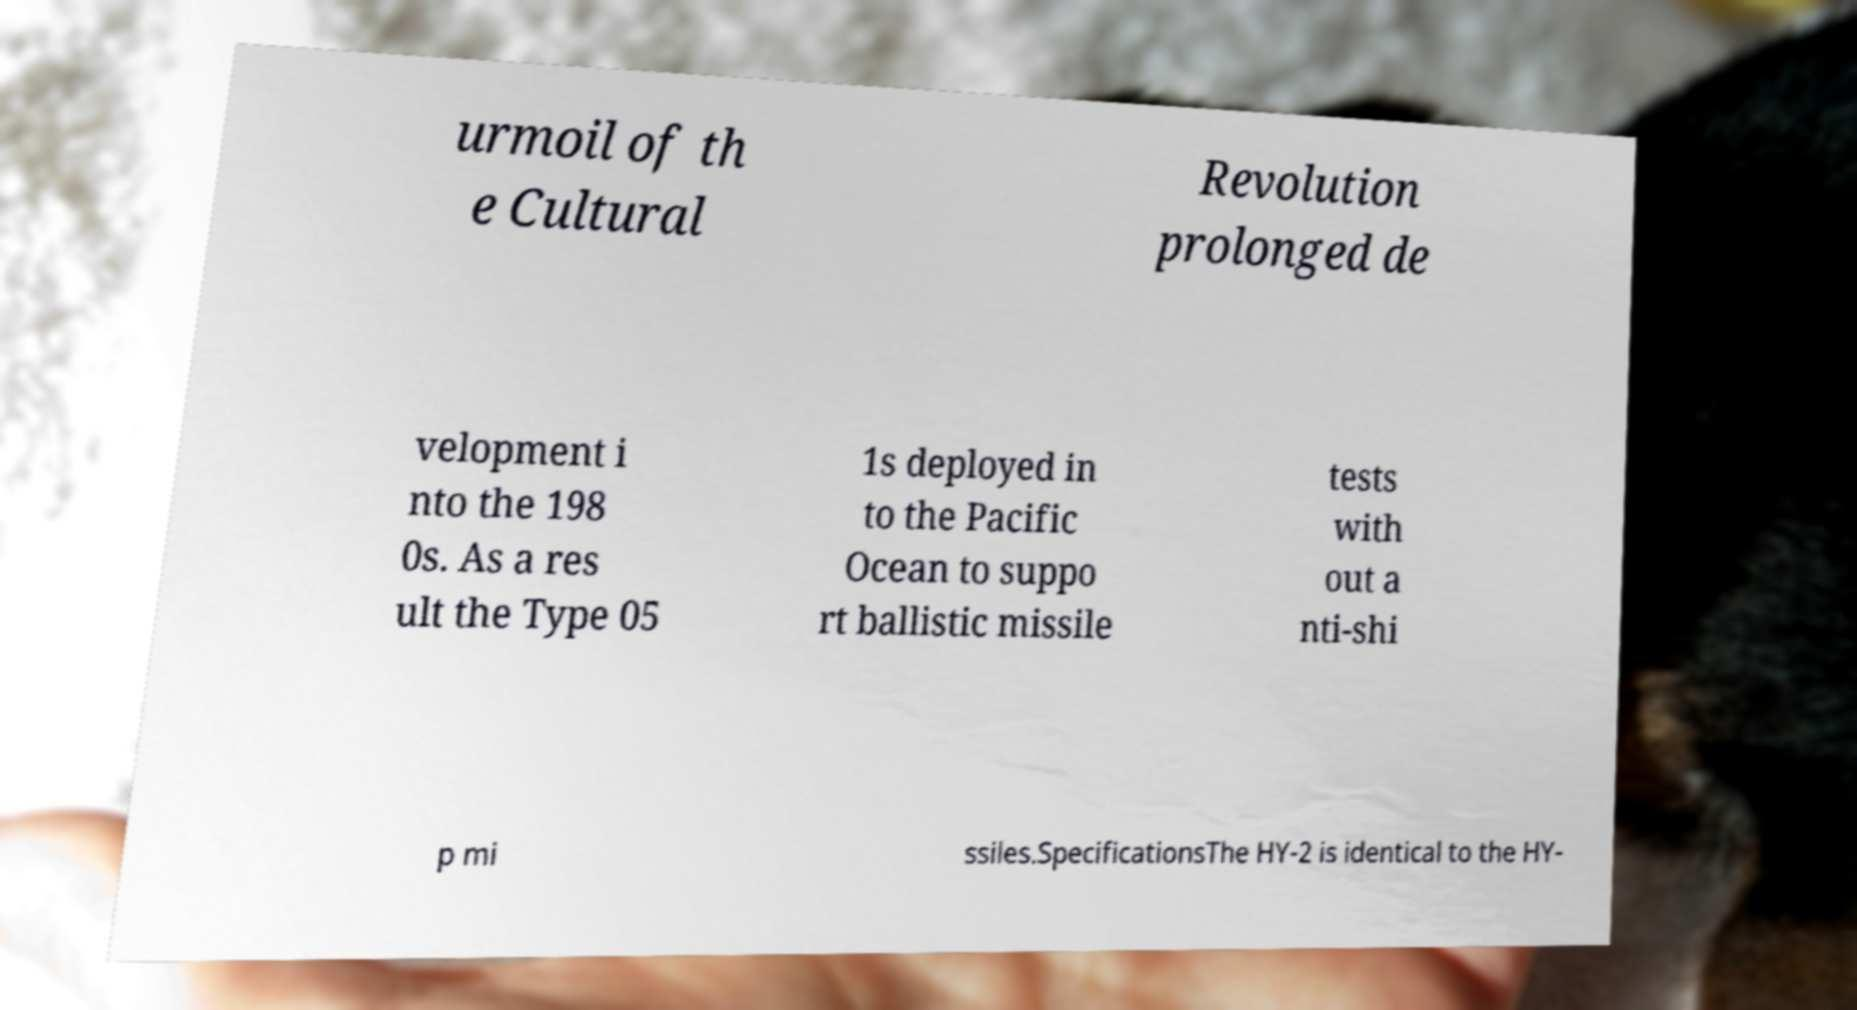For documentation purposes, I need the text within this image transcribed. Could you provide that? urmoil of th e Cultural Revolution prolonged de velopment i nto the 198 0s. As a res ult the Type 05 1s deployed in to the Pacific Ocean to suppo rt ballistic missile tests with out a nti-shi p mi ssiles.SpecificationsThe HY-2 is identical to the HY- 